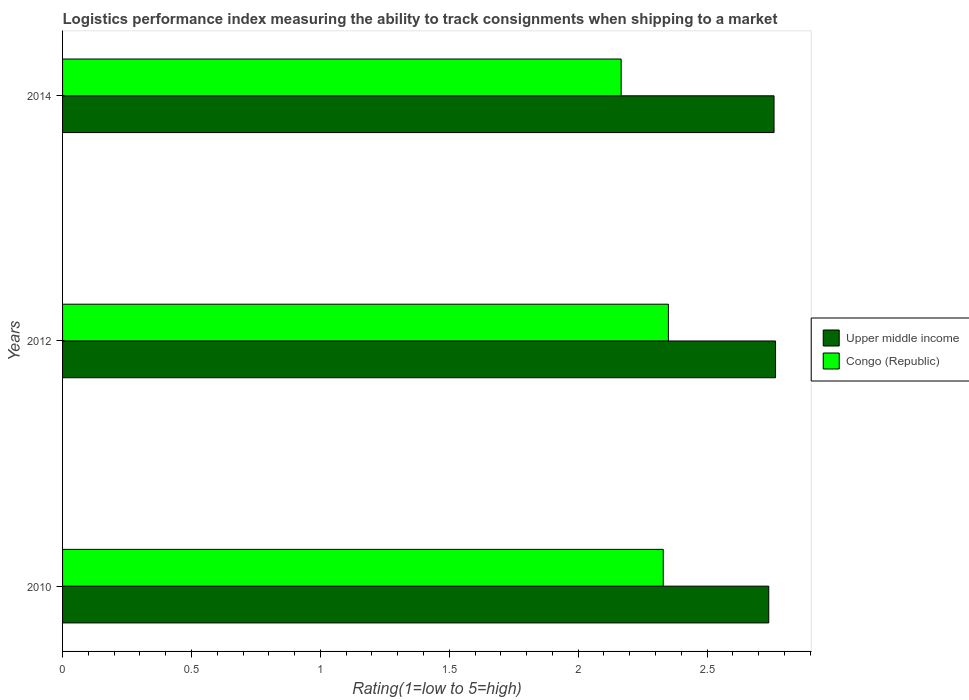How many groups of bars are there?
Keep it short and to the point. 3. In how many cases, is the number of bars for a given year not equal to the number of legend labels?
Ensure brevity in your answer.  0. What is the Logistic performance index in Upper middle income in 2014?
Keep it short and to the point. 2.76. Across all years, what is the maximum Logistic performance index in Congo (Republic)?
Your answer should be very brief. 2.35. Across all years, what is the minimum Logistic performance index in Upper middle income?
Keep it short and to the point. 2.74. What is the total Logistic performance index in Congo (Republic) in the graph?
Provide a succinct answer. 6.85. What is the difference between the Logistic performance index in Congo (Republic) in 2010 and that in 2014?
Ensure brevity in your answer.  0.16. What is the difference between the Logistic performance index in Congo (Republic) in 2010 and the Logistic performance index in Upper middle income in 2014?
Keep it short and to the point. -0.43. What is the average Logistic performance index in Upper middle income per year?
Make the answer very short. 2.75. In the year 2014, what is the difference between the Logistic performance index in Congo (Republic) and Logistic performance index in Upper middle income?
Your response must be concise. -0.59. What is the ratio of the Logistic performance index in Upper middle income in 2010 to that in 2014?
Your answer should be compact. 0.99. Is the Logistic performance index in Congo (Republic) in 2010 less than that in 2014?
Your answer should be compact. No. Is the difference between the Logistic performance index in Congo (Republic) in 2010 and 2012 greater than the difference between the Logistic performance index in Upper middle income in 2010 and 2012?
Provide a short and direct response. Yes. What is the difference between the highest and the second highest Logistic performance index in Congo (Republic)?
Ensure brevity in your answer.  0.02. What is the difference between the highest and the lowest Logistic performance index in Upper middle income?
Provide a short and direct response. 0.03. What does the 1st bar from the top in 2014 represents?
Keep it short and to the point. Congo (Republic). What does the 1st bar from the bottom in 2010 represents?
Your answer should be very brief. Upper middle income. How many bars are there?
Offer a very short reply. 6. What is the difference between two consecutive major ticks on the X-axis?
Provide a succinct answer. 0.5. Are the values on the major ticks of X-axis written in scientific E-notation?
Offer a terse response. No. Does the graph contain grids?
Make the answer very short. No. Where does the legend appear in the graph?
Your answer should be compact. Center right. What is the title of the graph?
Your answer should be compact. Logistics performance index measuring the ability to track consignments when shipping to a market. Does "Lao PDR" appear as one of the legend labels in the graph?
Provide a succinct answer. No. What is the label or title of the X-axis?
Offer a very short reply. Rating(1=low to 5=high). What is the Rating(1=low to 5=high) of Upper middle income in 2010?
Offer a very short reply. 2.74. What is the Rating(1=low to 5=high) of Congo (Republic) in 2010?
Your response must be concise. 2.33. What is the Rating(1=low to 5=high) of Upper middle income in 2012?
Keep it short and to the point. 2.77. What is the Rating(1=low to 5=high) in Congo (Republic) in 2012?
Your answer should be very brief. 2.35. What is the Rating(1=low to 5=high) of Upper middle income in 2014?
Offer a very short reply. 2.76. What is the Rating(1=low to 5=high) in Congo (Republic) in 2014?
Your answer should be compact. 2.17. Across all years, what is the maximum Rating(1=low to 5=high) of Upper middle income?
Your answer should be compact. 2.77. Across all years, what is the maximum Rating(1=low to 5=high) of Congo (Republic)?
Offer a terse response. 2.35. Across all years, what is the minimum Rating(1=low to 5=high) of Upper middle income?
Provide a short and direct response. 2.74. Across all years, what is the minimum Rating(1=low to 5=high) of Congo (Republic)?
Give a very brief answer. 2.17. What is the total Rating(1=low to 5=high) in Upper middle income in the graph?
Make the answer very short. 8.26. What is the total Rating(1=low to 5=high) in Congo (Republic) in the graph?
Your answer should be compact. 6.85. What is the difference between the Rating(1=low to 5=high) in Upper middle income in 2010 and that in 2012?
Your answer should be very brief. -0.03. What is the difference between the Rating(1=low to 5=high) of Congo (Republic) in 2010 and that in 2012?
Give a very brief answer. -0.02. What is the difference between the Rating(1=low to 5=high) in Upper middle income in 2010 and that in 2014?
Make the answer very short. -0.02. What is the difference between the Rating(1=low to 5=high) in Congo (Republic) in 2010 and that in 2014?
Keep it short and to the point. 0.16. What is the difference between the Rating(1=low to 5=high) of Upper middle income in 2012 and that in 2014?
Offer a very short reply. 0.01. What is the difference between the Rating(1=low to 5=high) in Congo (Republic) in 2012 and that in 2014?
Make the answer very short. 0.18. What is the difference between the Rating(1=low to 5=high) in Upper middle income in 2010 and the Rating(1=low to 5=high) in Congo (Republic) in 2012?
Your response must be concise. 0.39. What is the difference between the Rating(1=low to 5=high) in Upper middle income in 2010 and the Rating(1=low to 5=high) in Congo (Republic) in 2014?
Provide a short and direct response. 0.57. What is the difference between the Rating(1=low to 5=high) in Upper middle income in 2012 and the Rating(1=low to 5=high) in Congo (Republic) in 2014?
Provide a succinct answer. 0.6. What is the average Rating(1=low to 5=high) in Upper middle income per year?
Ensure brevity in your answer.  2.75. What is the average Rating(1=low to 5=high) in Congo (Republic) per year?
Provide a succinct answer. 2.28. In the year 2010, what is the difference between the Rating(1=low to 5=high) in Upper middle income and Rating(1=low to 5=high) in Congo (Republic)?
Ensure brevity in your answer.  0.41. In the year 2012, what is the difference between the Rating(1=low to 5=high) in Upper middle income and Rating(1=low to 5=high) in Congo (Republic)?
Provide a succinct answer. 0.42. In the year 2014, what is the difference between the Rating(1=low to 5=high) of Upper middle income and Rating(1=low to 5=high) of Congo (Republic)?
Offer a terse response. 0.59. What is the ratio of the Rating(1=low to 5=high) in Congo (Republic) in 2010 to that in 2012?
Make the answer very short. 0.99. What is the ratio of the Rating(1=low to 5=high) of Upper middle income in 2010 to that in 2014?
Offer a terse response. 0.99. What is the ratio of the Rating(1=low to 5=high) in Congo (Republic) in 2010 to that in 2014?
Provide a succinct answer. 1.08. What is the ratio of the Rating(1=low to 5=high) of Congo (Republic) in 2012 to that in 2014?
Keep it short and to the point. 1.08. What is the difference between the highest and the second highest Rating(1=low to 5=high) in Upper middle income?
Your answer should be very brief. 0.01. What is the difference between the highest and the lowest Rating(1=low to 5=high) of Upper middle income?
Give a very brief answer. 0.03. What is the difference between the highest and the lowest Rating(1=low to 5=high) of Congo (Republic)?
Keep it short and to the point. 0.18. 